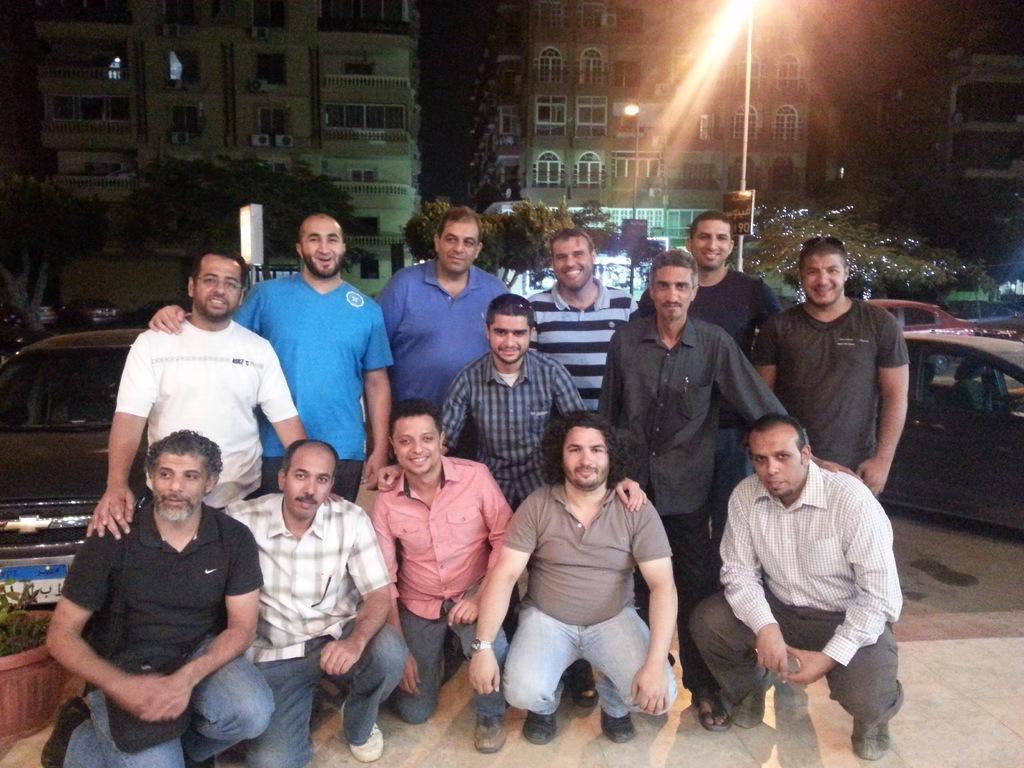Describe this image in one or two sentences. In this image there are a few people kneeled down, behind them there are a few people standing, all there people are posing for the camera with a smile on their face, behind them there are a few cars parked, behind the cars there is a lamp post and there are trees and buildings. 